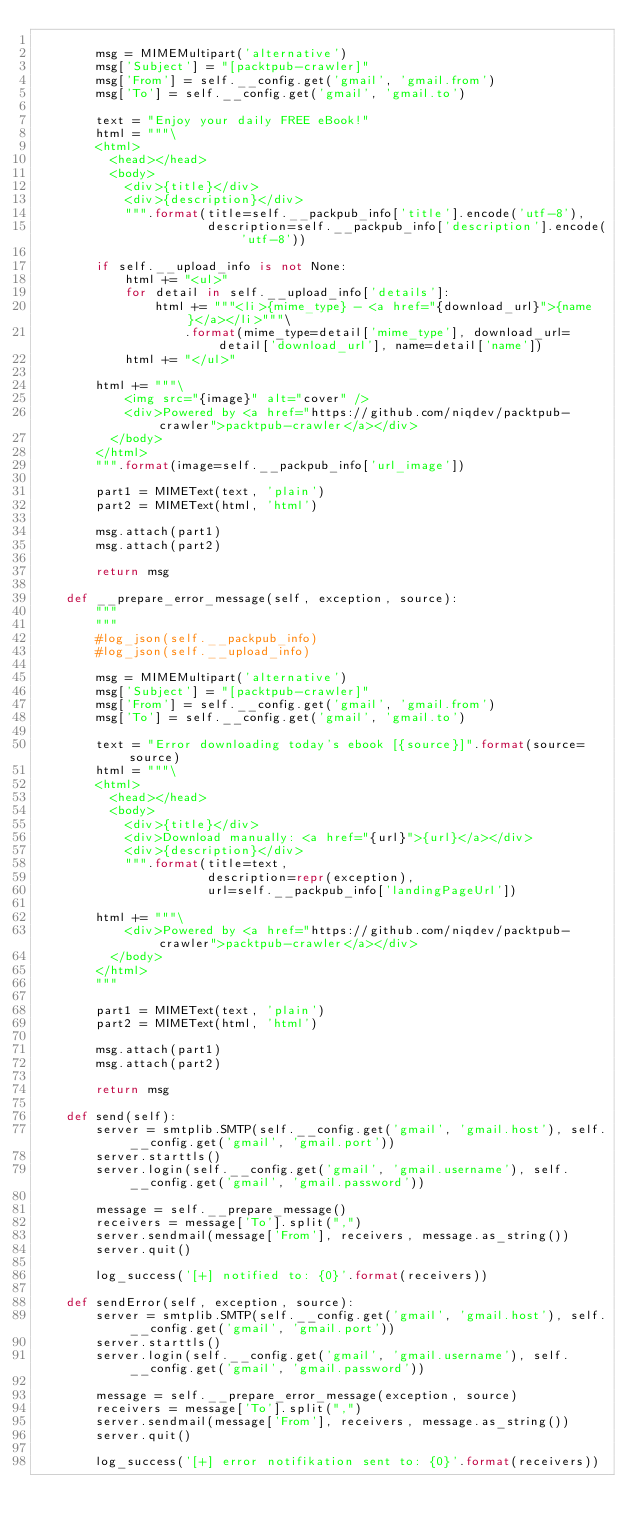Convert code to text. <code><loc_0><loc_0><loc_500><loc_500><_Python_>
        msg = MIMEMultipart('alternative')
        msg['Subject'] = "[packtpub-crawler]"
        msg['From'] = self.__config.get('gmail', 'gmail.from')
        msg['To'] = self.__config.get('gmail', 'gmail.to')

        text = "Enjoy your daily FREE eBook!"
        html = """\
        <html>
          <head></head>
          <body>
            <div>{title}</div>
            <div>{description}</div>
            """.format(title=self.__packpub_info['title'].encode('utf-8'),
                       description=self.__packpub_info['description'].encode('utf-8'))

        if self.__upload_info is not None:
            html += "<ul>"
            for detail in self.__upload_info['details']:
                html += """<li>{mime_type} - <a href="{download_url}">{name}</a></li>"""\
                    .format(mime_type=detail['mime_type'], download_url=detail['download_url'], name=detail['name'])
            html += "</ul>"

        html += """\
            <img src="{image}" alt="cover" />
            <div>Powered by <a href="https://github.com/niqdev/packtpub-crawler">packtpub-crawler</a></div>
          </body>
        </html>
        """.format(image=self.__packpub_info['url_image'])

        part1 = MIMEText(text, 'plain')
        part2 = MIMEText(html, 'html')

        msg.attach(part1)
        msg.attach(part2)

        return msg

    def __prepare_error_message(self, exception, source):
        """
        """
        #log_json(self.__packpub_info)
        #log_json(self.__upload_info)

        msg = MIMEMultipart('alternative')
        msg['Subject'] = "[packtpub-crawler]"
        msg['From'] = self.__config.get('gmail', 'gmail.from')
        msg['To'] = self.__config.get('gmail', 'gmail.to')

        text = "Error downloading today's ebook [{source}]".format(source=source)
        html = """\
        <html>
          <head></head>
          <body>
            <div>{title}</div>
            <div>Download manually: <a href="{url}">{url}</a></div>
            <div>{description}</div>
            """.format(title=text,
                       description=repr(exception),
                       url=self.__packpub_info['landingPageUrl'])

        html += """\
            <div>Powered by <a href="https://github.com/niqdev/packtpub-crawler">packtpub-crawler</a></div>
          </body>
        </html>
        """

        part1 = MIMEText(text, 'plain')
        part2 = MIMEText(html, 'html')

        msg.attach(part1)
        msg.attach(part2)

        return msg

    def send(self):
        server = smtplib.SMTP(self.__config.get('gmail', 'gmail.host'), self.__config.get('gmail', 'gmail.port'))
        server.starttls()
        server.login(self.__config.get('gmail', 'gmail.username'), self.__config.get('gmail', 'gmail.password'))

        message = self.__prepare_message()
        receivers = message['To'].split(",")
        server.sendmail(message['From'], receivers, message.as_string())
        server.quit()

        log_success('[+] notified to: {0}'.format(receivers))

    def sendError(self, exception, source):
        server = smtplib.SMTP(self.__config.get('gmail', 'gmail.host'), self.__config.get('gmail', 'gmail.port'))
        server.starttls()
        server.login(self.__config.get('gmail', 'gmail.username'), self.__config.get('gmail', 'gmail.password'))

        message = self.__prepare_error_message(exception, source)
        receivers = message['To'].split(",")
        server.sendmail(message['From'], receivers, message.as_string())
        server.quit()

        log_success('[+] error notifikation sent to: {0}'.format(receivers))
</code> 